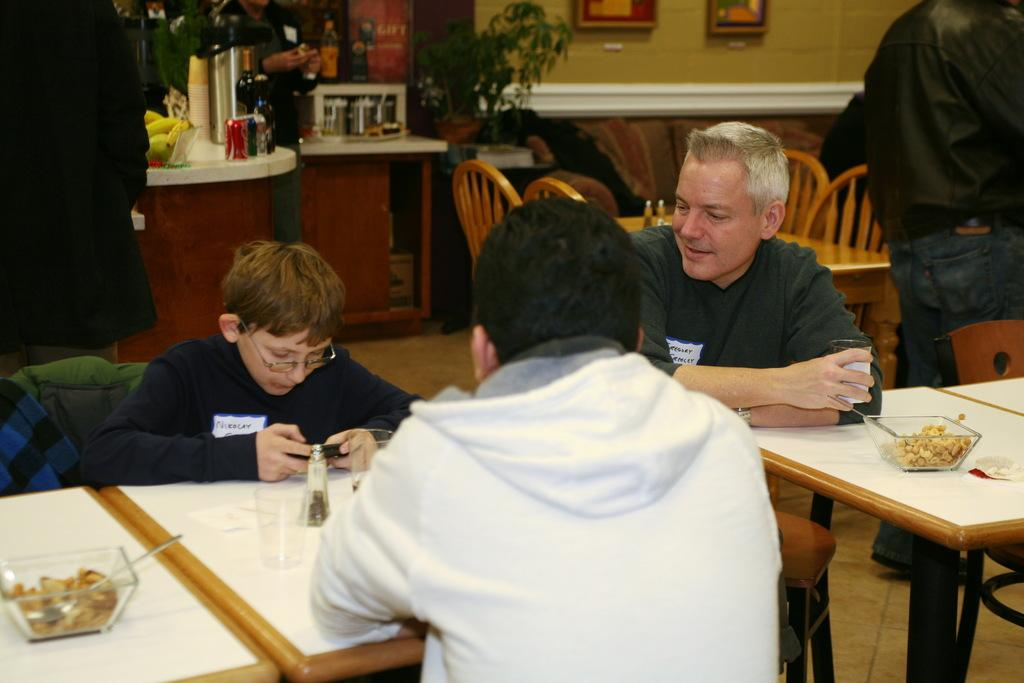Who or what can be seen in the image? There are people in the image. What type of furniture is present in the image? There are chairs and tables in the image. What objects are on the table? There are bowls and spoons on the table. Can you see any airplanes in the image? No, there are no airplanes present in the image. What type of string is being used to hold the pies in the image? There are no pies or strings present in the image. 